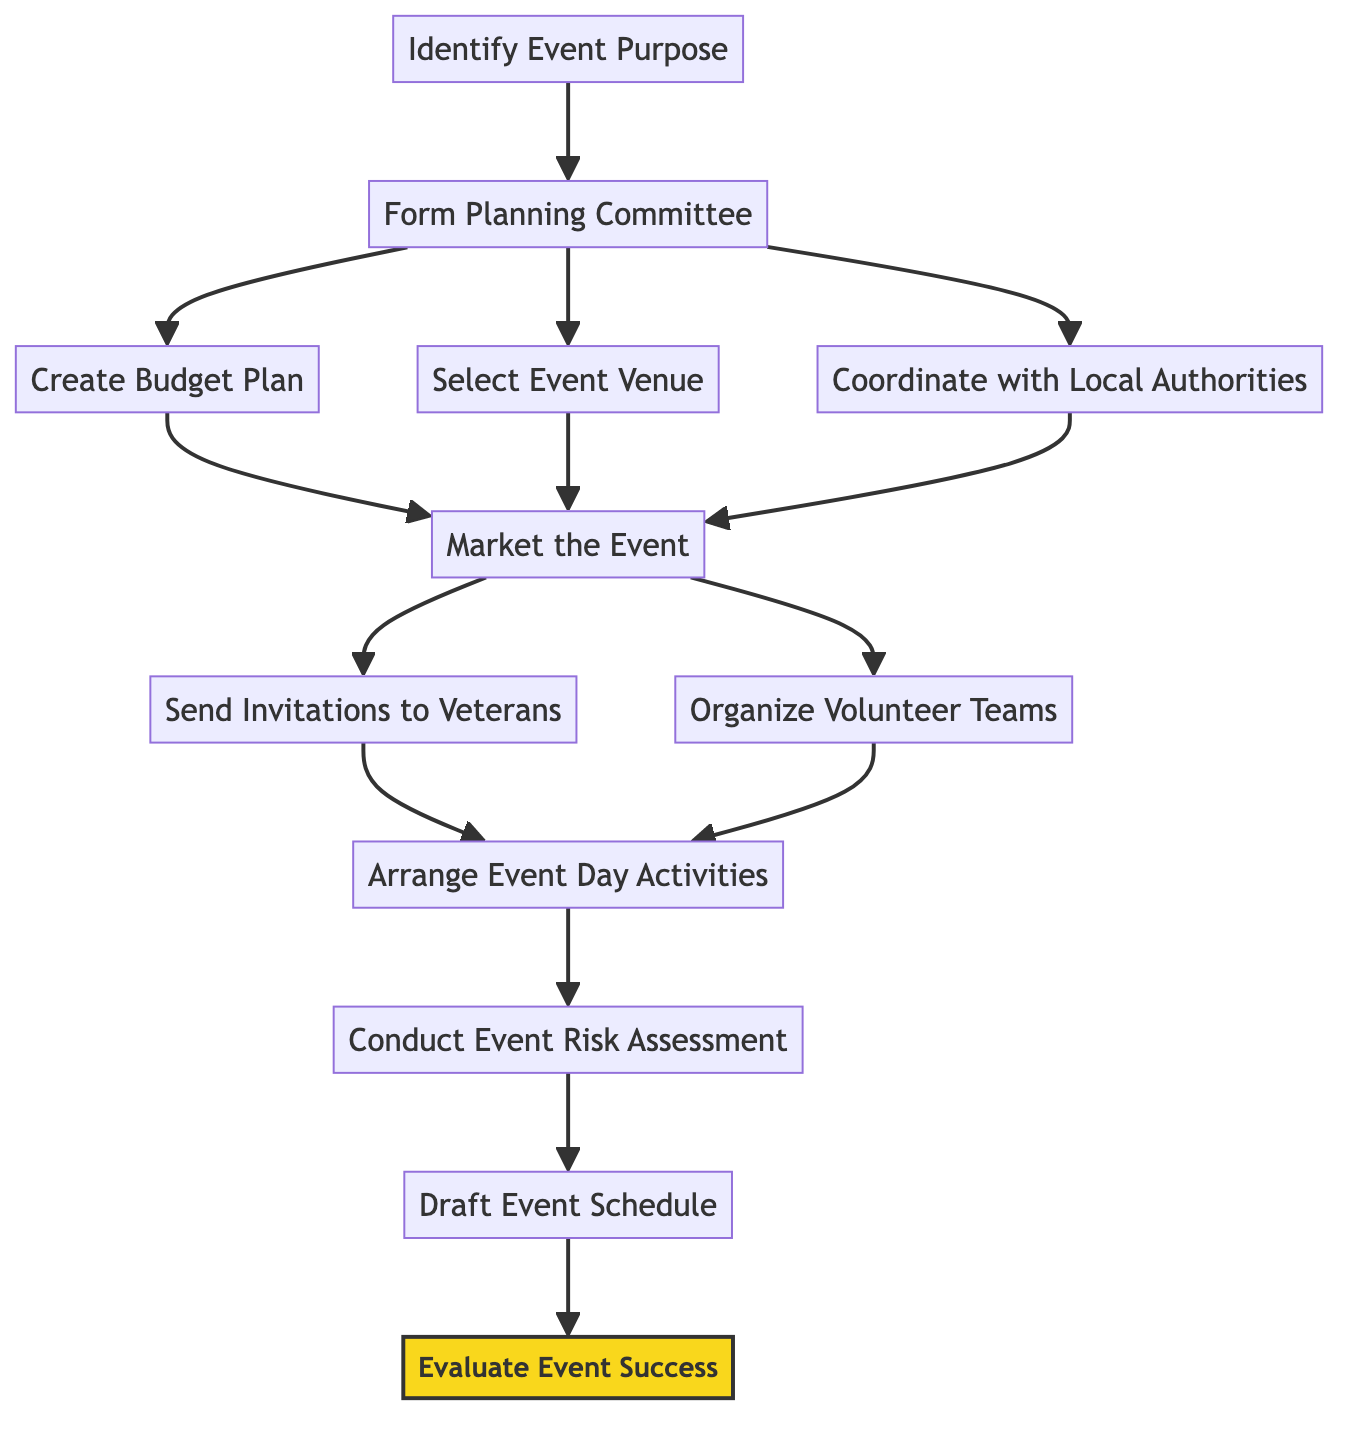What's the first activity in the diagram? The first node is "Identify Event Purpose," indicating it's the starting point of the process.
Answer: Identify Event Purpose How many activities are in the diagram? Counting all the activities listed in the diagram, there are a total of 12 activities present.
Answer: 12 What is the last activity in the process? The last node in the sequence is "Evaluate Event Success," which concludes the flow of the activities.
Answer: Evaluate Event Success Which activities come after "Market the Event"? After "Market the Event," the next two activities are "Send Invitations to Veterans" and "Organize Volunteer Teams."
Answer: Send Invitations to Veterans, Organize Volunteer Teams What does "Evaluate Event Success" follow? "Evaluate Event Success" follows "Draft Event Schedule," which is the penultimate activity in the flow.
Answer: Draft Event Schedule How many activities follow the "Form Planning Committee" activity? The "Form Planning Committee" activity leads to three subsequent activities: "Create Budget Plan," "Select Event Venue," and "Coordinate with Local Authorities," totaling three activities.
Answer: 3 Which activities must be completed before "Market the Event" can start? Before "Market the Event" can be initiated, all three activities "Create Budget Plan," "Select Event Venue," and "Coordinate with Local Authorities" must be completed.
Answer: Create Budget Plan, Select Event Venue, Coordinate with Local Authorities What unique structure do activity diagrams represent? Activity diagrams illustrate workflows and processes, typically displaying activities and their sequence of execution in a clear, visual manner.
Answer: Workflows and processes 